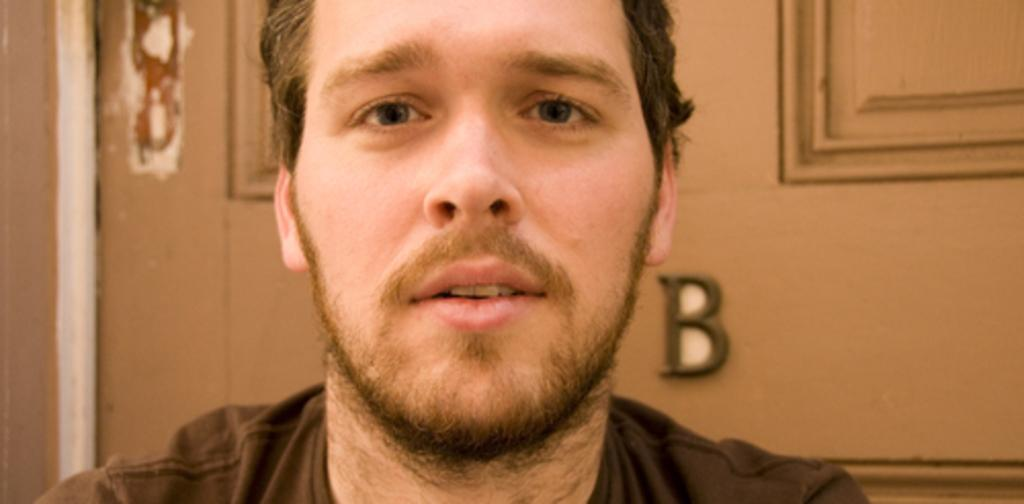What is present in the image? There is a person in the image. What is the person wearing? The person is wearing a black color shirt. What can be seen in the background of the image? There is a door in the background of the image. What colors are present on the door? The door has brown and cream colors. What type of chin can be seen on the scarecrow in the image? There is no scarecrow present in the image, and therefore no chin to describe. 